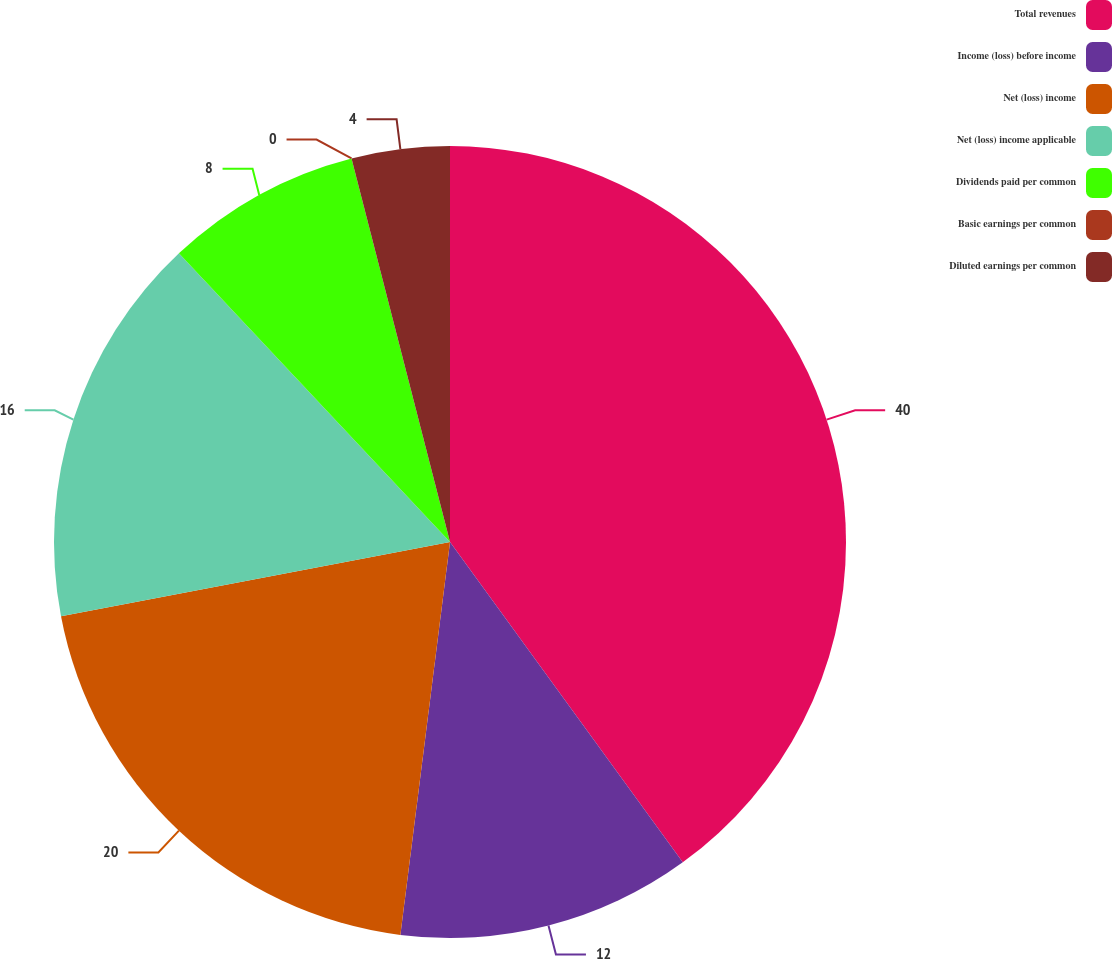Convert chart. <chart><loc_0><loc_0><loc_500><loc_500><pie_chart><fcel>Total revenues<fcel>Income (loss) before income<fcel>Net (loss) income<fcel>Net (loss) income applicable<fcel>Dividends paid per common<fcel>Basic earnings per common<fcel>Diluted earnings per common<nl><fcel>40.0%<fcel>12.0%<fcel>20.0%<fcel>16.0%<fcel>8.0%<fcel>0.0%<fcel>4.0%<nl></chart> 